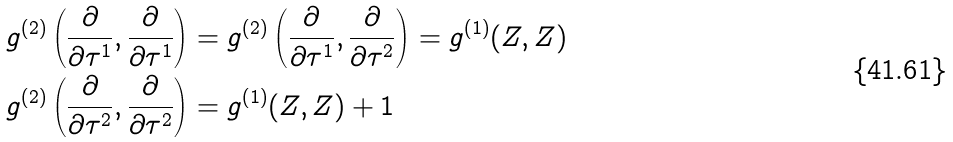Convert formula to latex. <formula><loc_0><loc_0><loc_500><loc_500>g ^ { ( 2 ) } \left ( \frac { \partial } { \partial \tau ^ { 1 } } , \frac { \partial } { \partial \tau ^ { 1 } } \right ) & = g ^ { ( 2 ) } \left ( \frac { \partial } { \partial \tau ^ { 1 } } , \frac { \partial } { \partial \tau ^ { 2 } } \right ) = g ^ { ( 1 ) } ( Z , Z ) \\ g ^ { ( 2 ) } \left ( \frac { \partial } { \partial \tau ^ { 2 } } , \frac { \partial } { \partial \tau ^ { 2 } } \right ) & = g ^ { ( 1 ) } ( Z , Z ) + 1</formula> 